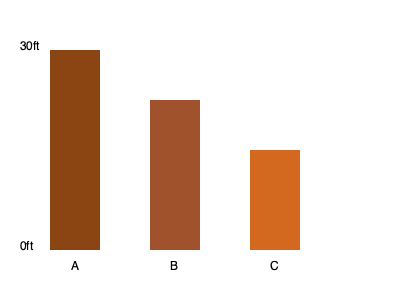President Trump's border wall sections A, B, and C are shown above. If the height of section A is 30 feet, what is the total combined height of sections B and C in feet? To solve this problem, we need to follow these steps:

1. Identify the height of section A: 30 feet
2. Observe that the graph shows A as the tallest section, occupying the full height of the scale (0ft to 30ft)
3. Compare the heights of sections B and C to A:
   - Section B appears to be 3/4 the height of A
   - Section C appears to be 1/2 the height of A
4. Calculate the heights of B and C:
   - Height of B = $30 \times \frac{3}{4} = 22.5$ feet
   - Height of C = $30 \times \frac{1}{2} = 15$ feet
5. Sum the heights of B and C:
   $22.5 + 15 = 37.5$ feet

Therefore, the total combined height of sections B and C is 37.5 feet.
Answer: 37.5 feet 